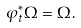Convert formula to latex. <formula><loc_0><loc_0><loc_500><loc_500>\varphi _ { t } ^ { * } \Omega = \Omega .</formula> 